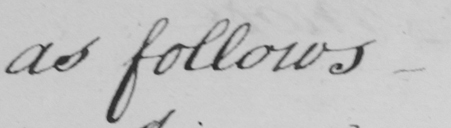Can you tell me what this handwritten text says? as follows_ 